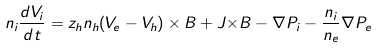Convert formula to latex. <formula><loc_0><loc_0><loc_500><loc_500>n _ { i } \frac { d { V } _ { i } } { d t } = z _ { h } n _ { h } ( { V } _ { e } - { V } _ { h } ) \times { B } + { J } { \times } { B } - \nabla { P _ { i } } - \frac { n _ { i } } { n _ { e } } \nabla P _ { e }</formula> 